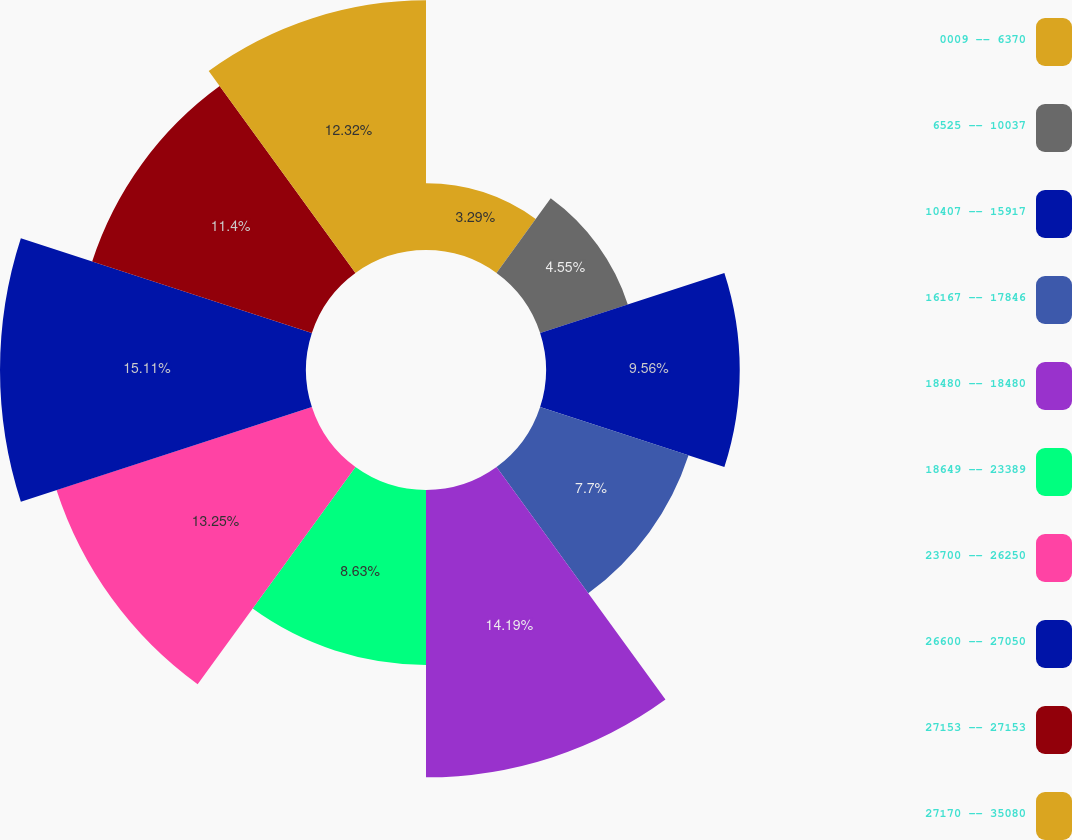Convert chart. <chart><loc_0><loc_0><loc_500><loc_500><pie_chart><fcel>0009 -- 6370<fcel>6525 -- 10037<fcel>10407 -- 15917<fcel>16167 -- 17846<fcel>18480 -- 18480<fcel>18649 -- 23389<fcel>23700 -- 26250<fcel>26600 -- 27050<fcel>27153 -- 27153<fcel>27170 -- 35080<nl><fcel>3.29%<fcel>4.55%<fcel>9.56%<fcel>7.7%<fcel>14.18%<fcel>8.63%<fcel>13.25%<fcel>15.1%<fcel>11.4%<fcel>12.32%<nl></chart> 